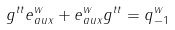<formula> <loc_0><loc_0><loc_500><loc_500>g ^ { t t } e ^ { w } _ { a u x } + e ^ { w } _ { a u x } g ^ { t t } = q _ { - 1 } ^ { w }</formula> 